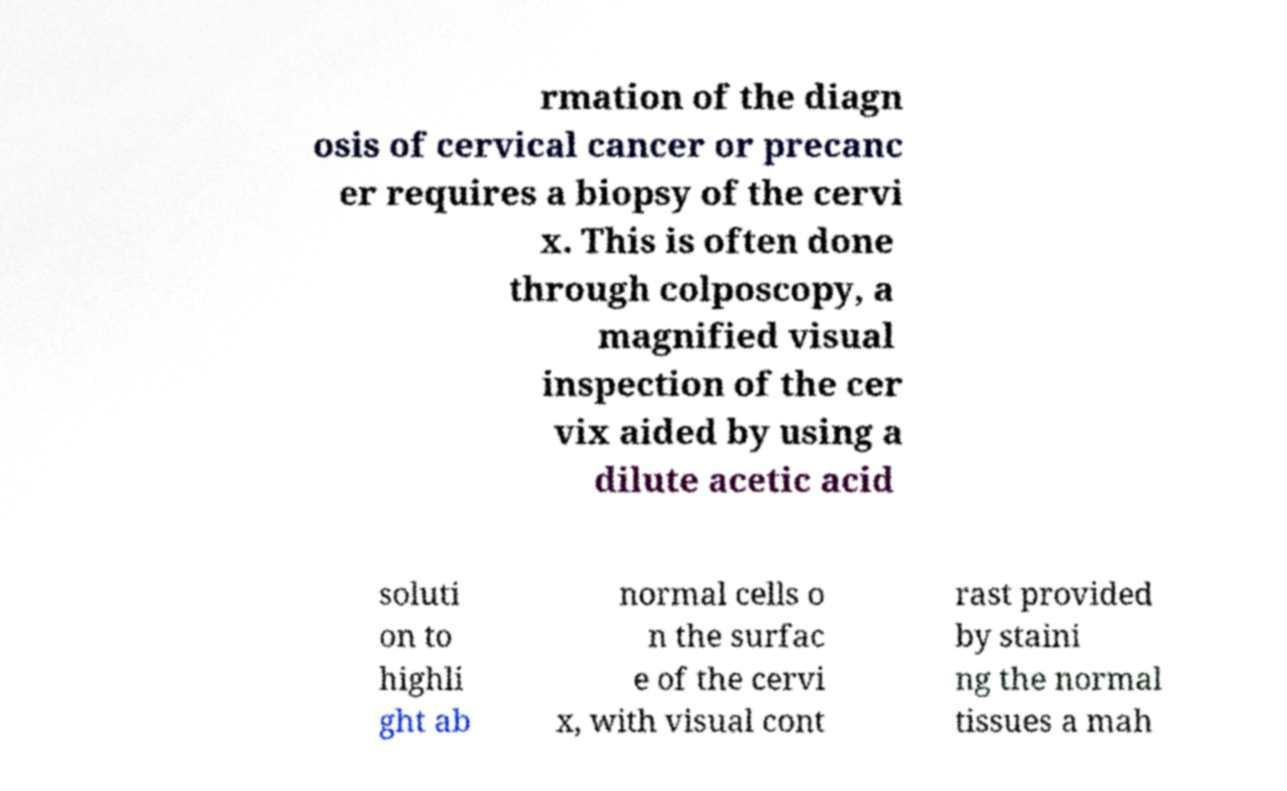Please read and relay the text visible in this image. What does it say? rmation of the diagn osis of cervical cancer or precanc er requires a biopsy of the cervi x. This is often done through colposcopy, a magnified visual inspection of the cer vix aided by using a dilute acetic acid soluti on to highli ght ab normal cells o n the surfac e of the cervi x, with visual cont rast provided by staini ng the normal tissues a mah 